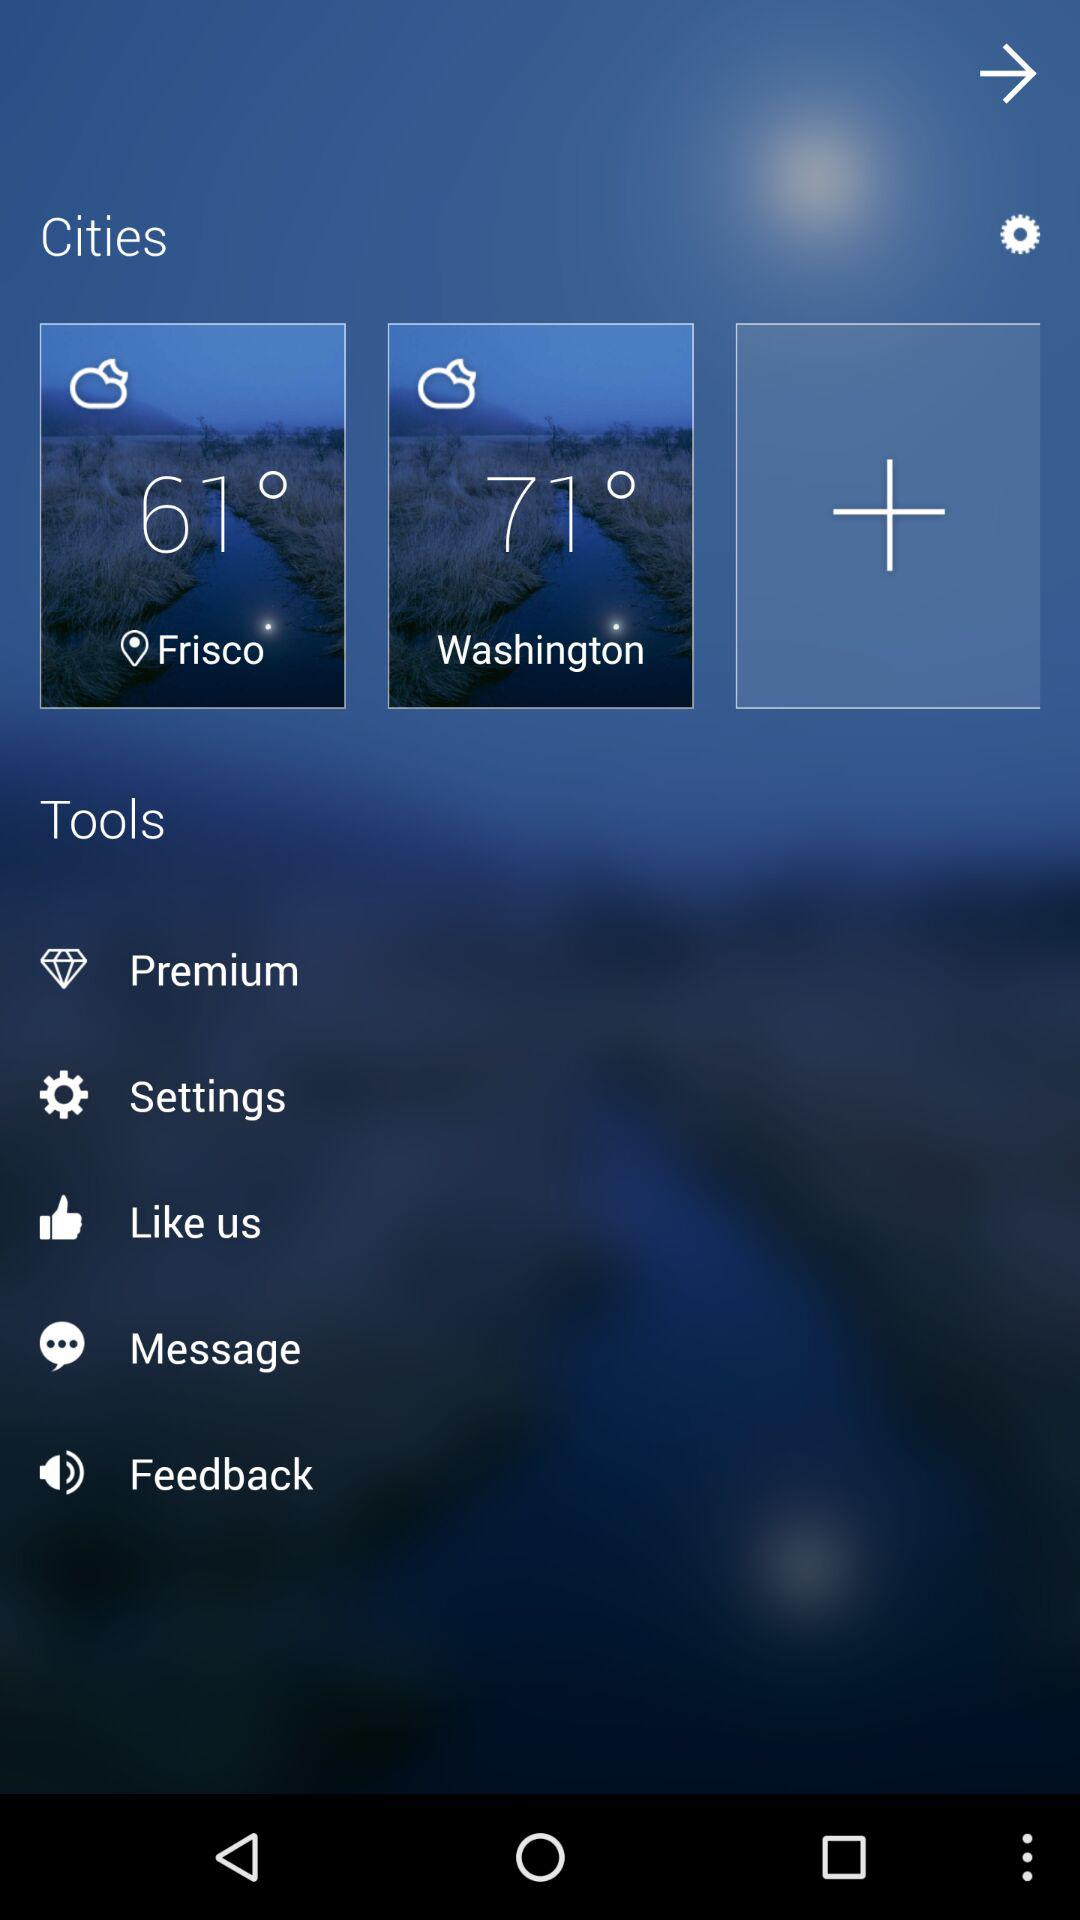What is the temperature in Washington? The temperature in Washington is 71 °. 